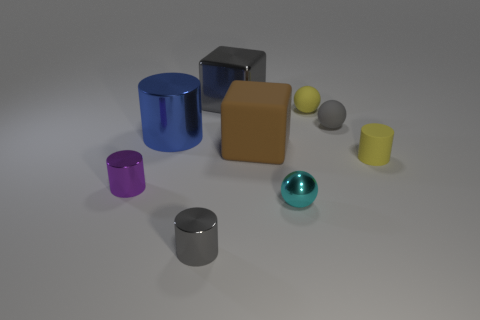Subtract all gray rubber balls. How many balls are left? 2 Subtract all yellow cylinders. How many cylinders are left? 3 Add 1 gray cubes. How many objects exist? 10 Subtract all cylinders. How many objects are left? 5 Subtract all blue cylinders. How many yellow cubes are left? 0 Subtract all blue cubes. Subtract all large brown matte blocks. How many objects are left? 8 Add 7 small gray metal objects. How many small gray metal objects are left? 8 Add 7 small purple things. How many small purple things exist? 8 Subtract 1 yellow spheres. How many objects are left? 8 Subtract 1 cylinders. How many cylinders are left? 3 